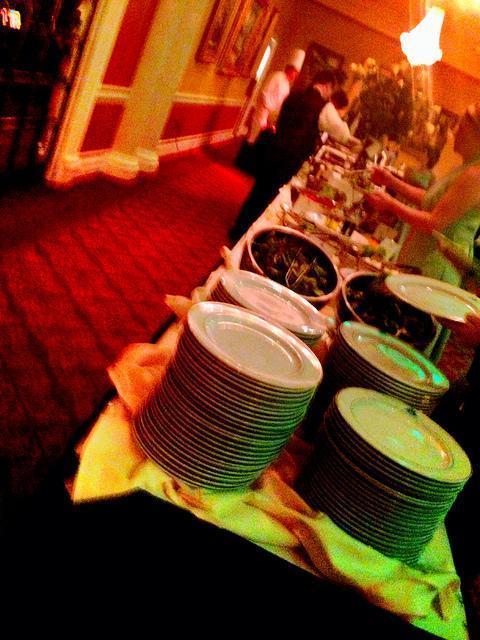How many people are visible?
Give a very brief answer. 3. How many bowls are there?
Give a very brief answer. 2. 